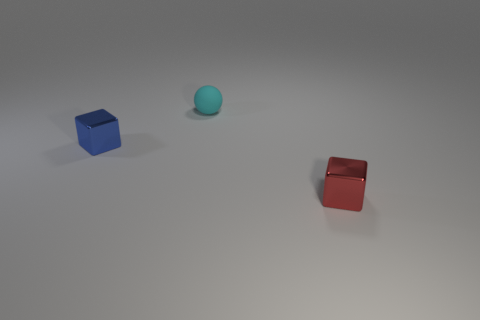Do the small metallic cube behind the tiny red cube and the block that is in front of the small blue metal cube have the same color?
Provide a short and direct response. No. Are there any cyan balls that have the same material as the cyan object?
Offer a terse response. No. Are there the same number of tiny objects behind the small blue thing and red things that are behind the tiny red thing?
Provide a succinct answer. No. What size is the blue metallic object that is in front of the small cyan rubber object?
Make the answer very short. Small. There is a tiny cube in front of the metal cube that is on the left side of the red block; what is its material?
Make the answer very short. Metal. There is a cube that is behind the cube right of the cyan sphere; how many tiny balls are in front of it?
Keep it short and to the point. 0. Does the cube that is to the right of the cyan sphere have the same material as the tiny cube that is left of the cyan matte thing?
Ensure brevity in your answer.  Yes. What number of tiny blue metallic things are the same shape as the small cyan object?
Your answer should be compact. 0. Is the number of small cyan spheres that are to the right of the small rubber sphere greater than the number of red metallic objects?
Your answer should be very brief. No. What is the shape of the small shiny thing on the right side of the matte object behind the metal cube that is behind the red thing?
Provide a succinct answer. Cube. 